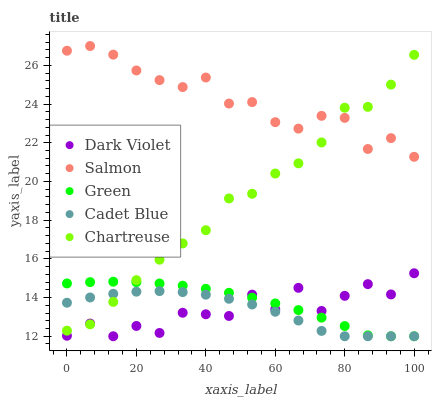Does Cadet Blue have the minimum area under the curve?
Answer yes or no. Yes. Does Salmon have the maximum area under the curve?
Answer yes or no. Yes. Does Chartreuse have the minimum area under the curve?
Answer yes or no. No. Does Chartreuse have the maximum area under the curve?
Answer yes or no. No. Is Green the smoothest?
Answer yes or no. Yes. Is Dark Violet the roughest?
Answer yes or no. Yes. Is Chartreuse the smoothest?
Answer yes or no. No. Is Chartreuse the roughest?
Answer yes or no. No. Does Green have the lowest value?
Answer yes or no. Yes. Does Chartreuse have the lowest value?
Answer yes or no. No. Does Salmon have the highest value?
Answer yes or no. Yes. Does Chartreuse have the highest value?
Answer yes or no. No. Is Dark Violet less than Salmon?
Answer yes or no. Yes. Is Salmon greater than Green?
Answer yes or no. Yes. Does Cadet Blue intersect Dark Violet?
Answer yes or no. Yes. Is Cadet Blue less than Dark Violet?
Answer yes or no. No. Is Cadet Blue greater than Dark Violet?
Answer yes or no. No. Does Dark Violet intersect Salmon?
Answer yes or no. No. 